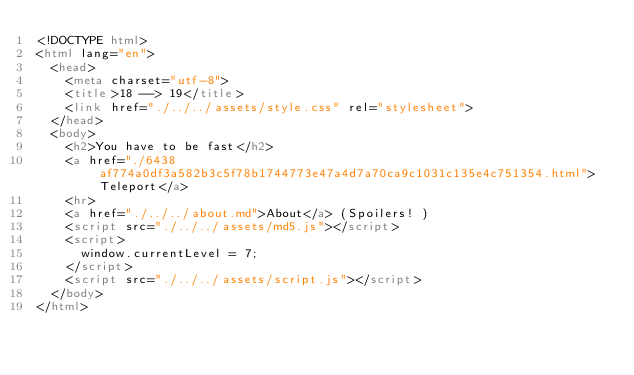<code> <loc_0><loc_0><loc_500><loc_500><_HTML_><!DOCTYPE html>
<html lang="en">
  <head>
    <meta charset="utf-8">
    <title>18 --> 19</title>
    <link href="./../../assets/style.css" rel="stylesheet">
  </head>
  <body>
    <h2>You have to be fast</h2>
    <a href="./6438af774a0df3a582b3c5f78b1744773e47a4d7a70ca9c1031c135e4c751354.html">Teleport</a>
    <hr>
    <a href="./../../about.md">About</a> (Spoilers! )
    <script src="./../../assets/md5.js"></script>
    <script>
      window.currentLevel = 7;
    </script>
    <script src="./../../assets/script.js"></script>
  </body>
</html></code> 